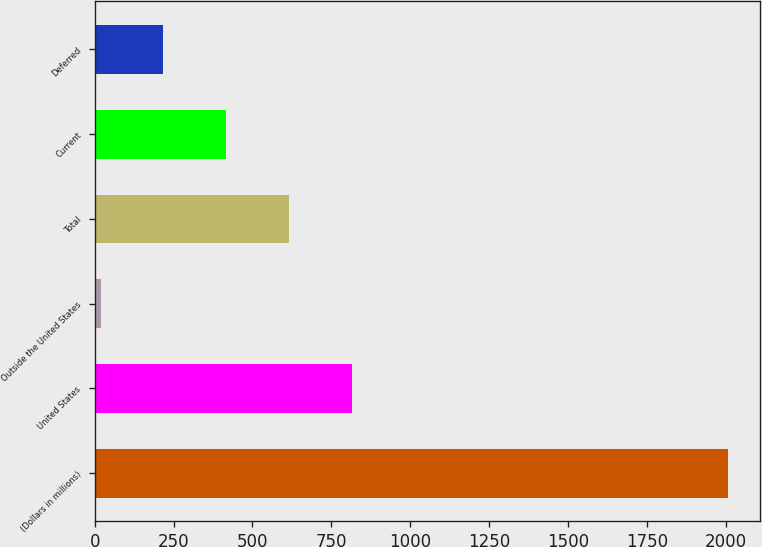<chart> <loc_0><loc_0><loc_500><loc_500><bar_chart><fcel>(Dollars in millions)<fcel>United States<fcel>Outside the United States<fcel>Total<fcel>Current<fcel>Deferred<nl><fcel>2007<fcel>814.2<fcel>19<fcel>615.4<fcel>416.6<fcel>217.8<nl></chart> 